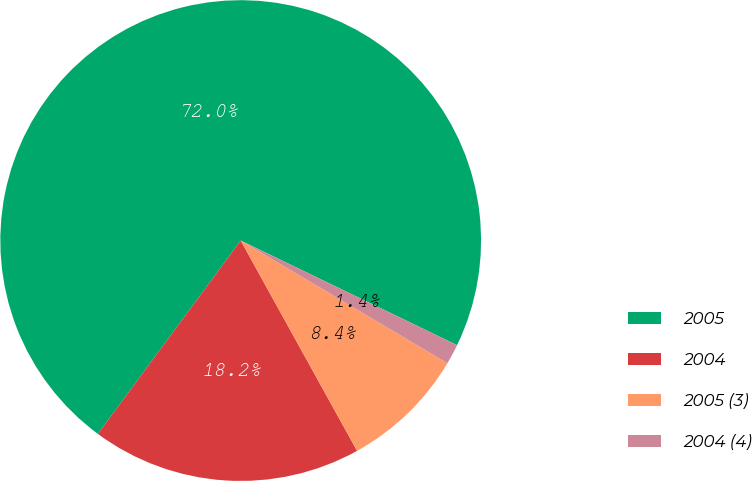<chart> <loc_0><loc_0><loc_500><loc_500><pie_chart><fcel>2005<fcel>2004<fcel>2005 (3)<fcel>2004 (4)<nl><fcel>72.04%<fcel>18.17%<fcel>8.43%<fcel>1.36%<nl></chart> 